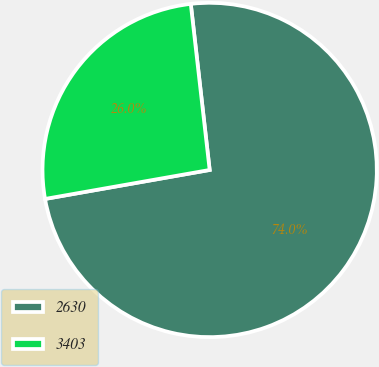Convert chart. <chart><loc_0><loc_0><loc_500><loc_500><pie_chart><fcel>2630<fcel>3403<nl><fcel>74.03%<fcel>25.97%<nl></chart> 